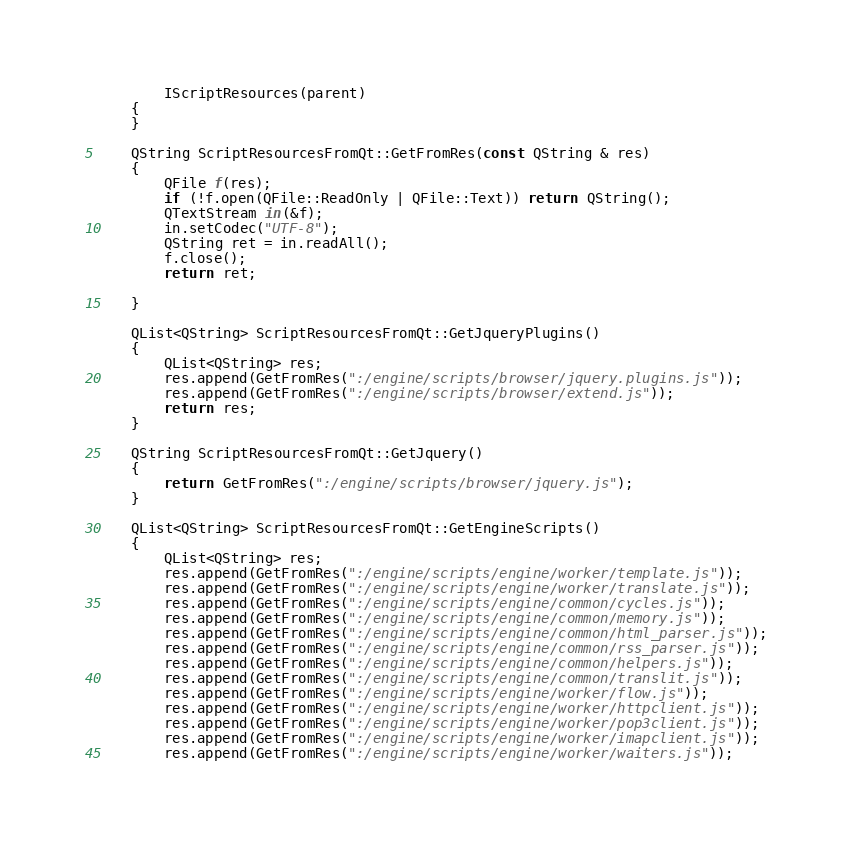Convert code to text. <code><loc_0><loc_0><loc_500><loc_500><_C++_>        IScriptResources(parent)
    {
    }

    QString ScriptResourcesFromQt::GetFromRes(const QString & res)
    {
        QFile f(res);
        if (!f.open(QFile::ReadOnly | QFile::Text)) return QString();
        QTextStream in(&f);
        in.setCodec("UTF-8");
        QString ret = in.readAll();
        f.close();
        return ret;

    }

    QList<QString> ScriptResourcesFromQt::GetJqueryPlugins()
    {
        QList<QString> res;
        res.append(GetFromRes(":/engine/scripts/browser/jquery.plugins.js"));
        res.append(GetFromRes(":/engine/scripts/browser/extend.js"));
        return res;
    }

    QString ScriptResourcesFromQt::GetJquery()
    {
        return GetFromRes(":/engine/scripts/browser/jquery.js");
    }

    QList<QString> ScriptResourcesFromQt::GetEngineScripts()
    {
        QList<QString> res;
        res.append(GetFromRes(":/engine/scripts/engine/worker/template.js"));
        res.append(GetFromRes(":/engine/scripts/engine/worker/translate.js"));
        res.append(GetFromRes(":/engine/scripts/engine/common/cycles.js"));
        res.append(GetFromRes(":/engine/scripts/engine/common/memory.js"));
        res.append(GetFromRes(":/engine/scripts/engine/common/html_parser.js"));
        res.append(GetFromRes(":/engine/scripts/engine/common/rss_parser.js"));
        res.append(GetFromRes(":/engine/scripts/engine/common/helpers.js"));
        res.append(GetFromRes(":/engine/scripts/engine/common/translit.js"));
        res.append(GetFromRes(":/engine/scripts/engine/worker/flow.js"));
        res.append(GetFromRes(":/engine/scripts/engine/worker/httpclient.js"));
        res.append(GetFromRes(":/engine/scripts/engine/worker/pop3client.js"));
        res.append(GetFromRes(":/engine/scripts/engine/worker/imapclient.js"));
        res.append(GetFromRes(":/engine/scripts/engine/worker/waiters.js"));</code> 